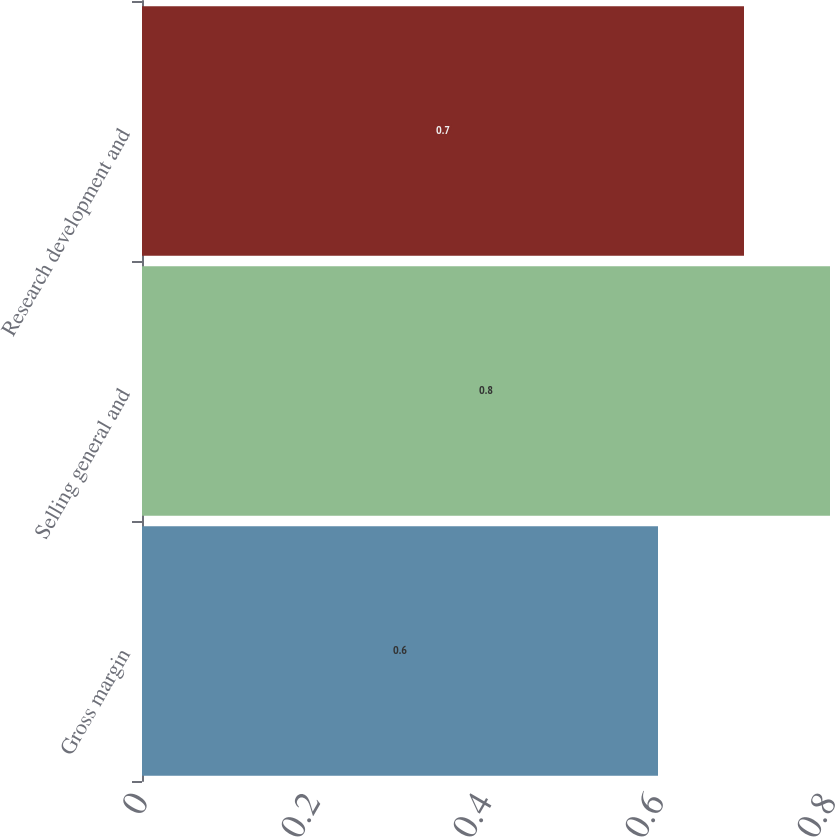<chart> <loc_0><loc_0><loc_500><loc_500><bar_chart><fcel>Gross margin<fcel>Selling general and<fcel>Research development and<nl><fcel>0.6<fcel>0.8<fcel>0.7<nl></chart> 